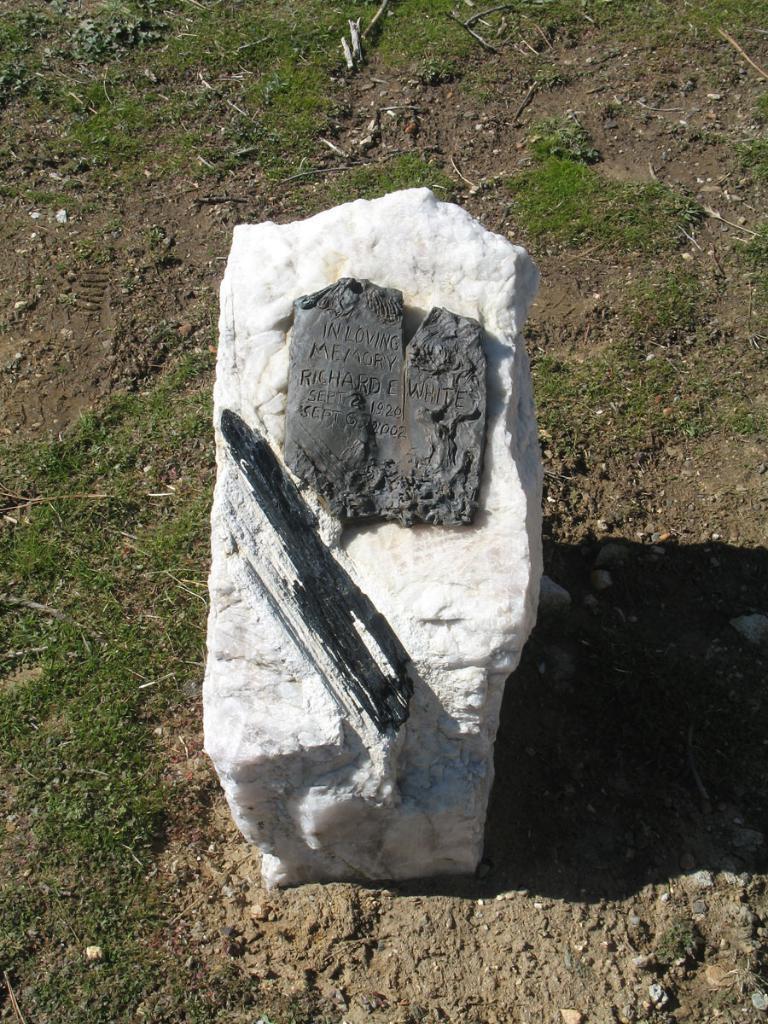Describe this image in one or two sentences. In this image we can see a stone on the ground, on the stone there is a some text and in the image we can see some grass. 